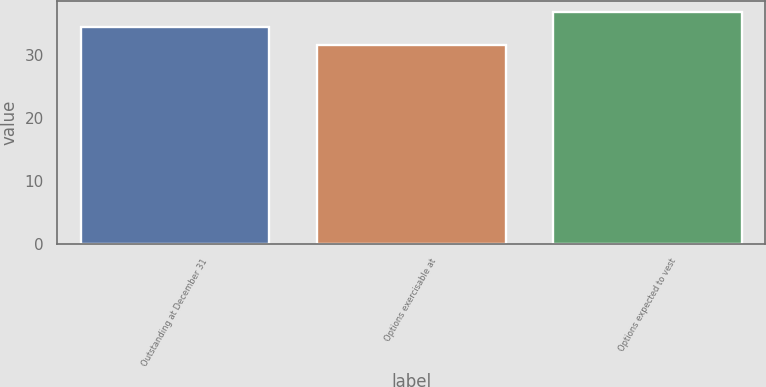<chart> <loc_0><loc_0><loc_500><loc_500><bar_chart><fcel>Outstanding at December 31<fcel>Options exercisable at<fcel>Options expected to vest<nl><fcel>34.41<fcel>31.53<fcel>36.73<nl></chart> 